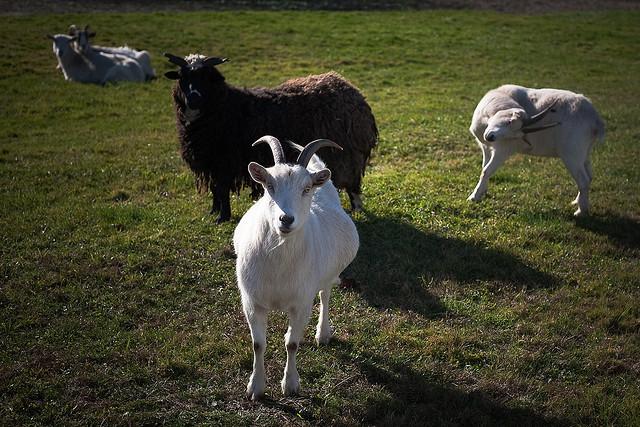Are the animals all the same color?
Give a very brief answer. No. Are these animal in a barn?
Short answer required. No. Do these animals eat grass?
Write a very short answer. Yes. What animals are in this photo?
Concise answer only. Goats. 